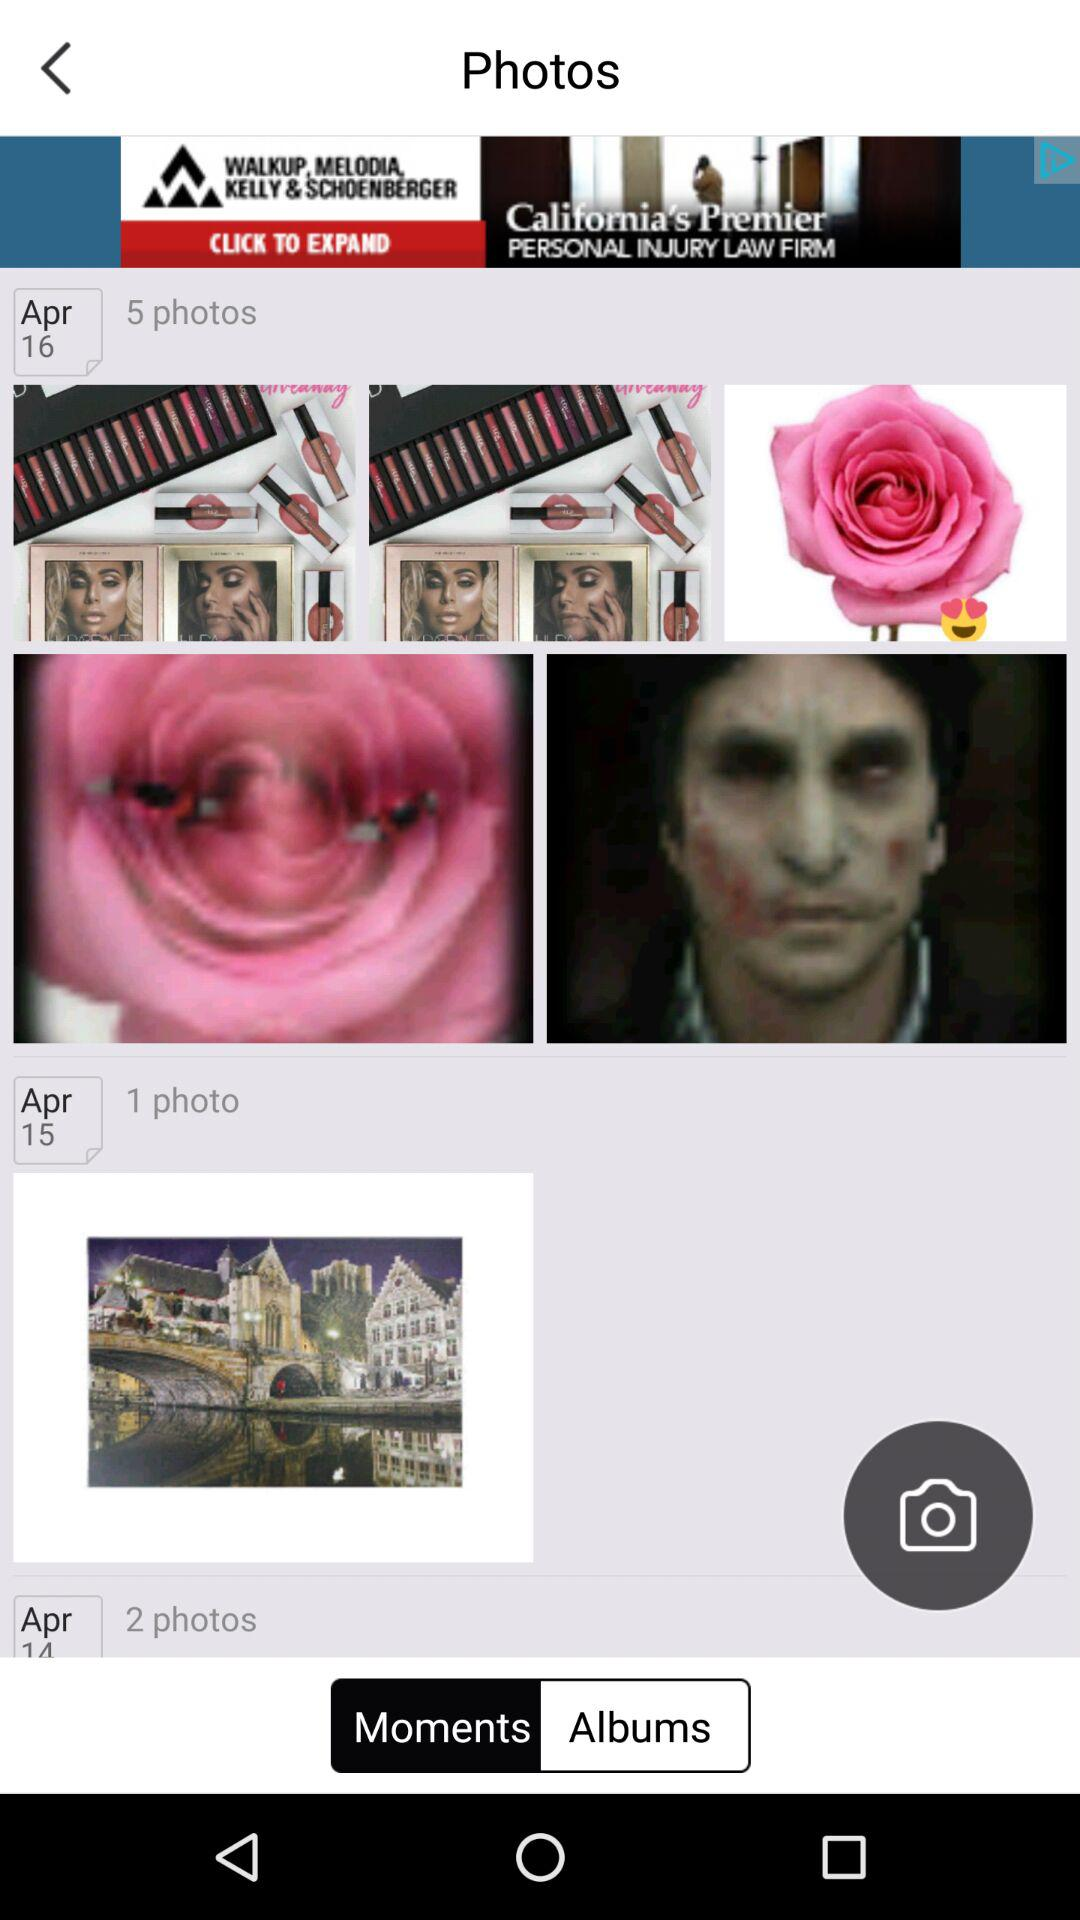How many photos were taken on April 16th?
Answer the question using a single word or phrase. 5 